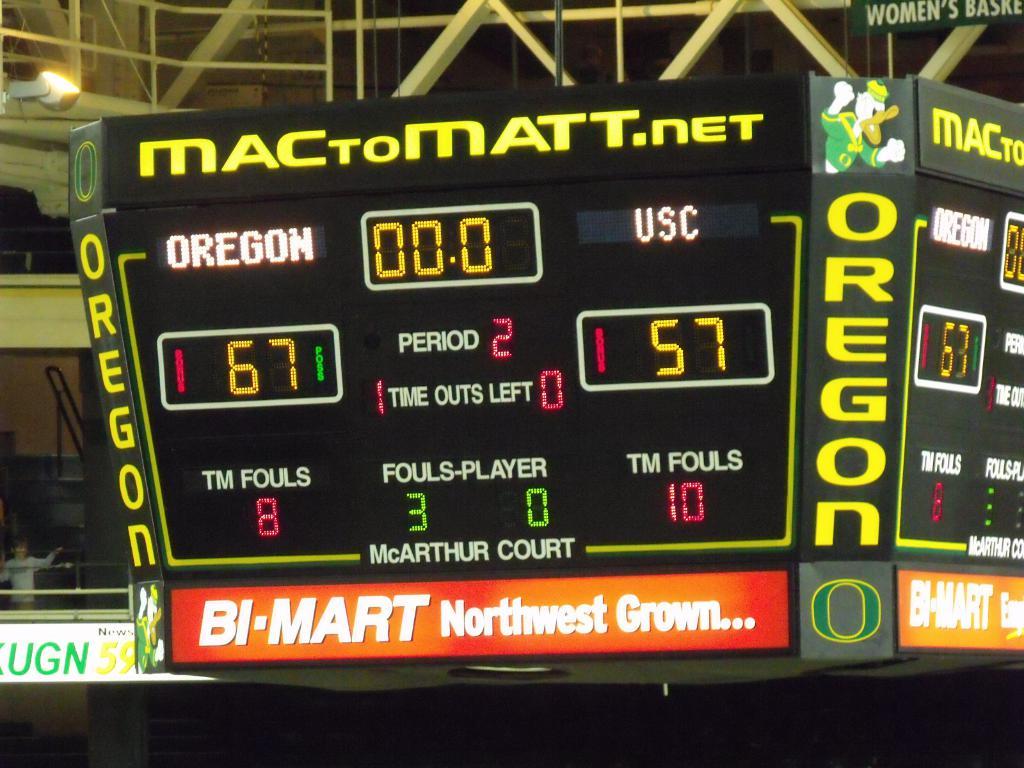How many points does oregon have?
Ensure brevity in your answer.  67. How many points did usc have?
Give a very brief answer. 57. 